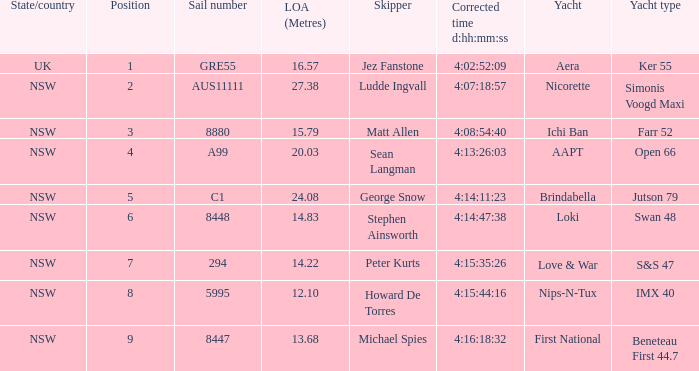For a boat with the correct time of 4:15:35:26, what is the complete sail distance? 14.22. Can you parse all the data within this table? {'header': ['State/country', 'Position', 'Sail number', 'LOA (Metres)', 'Skipper', 'Corrected time d:hh:mm:ss', 'Yacht', 'Yacht type'], 'rows': [['UK', '1', 'GRE55', '16.57', 'Jez Fanstone', '4:02:52:09', 'Aera', 'Ker 55'], ['NSW', '2', 'AUS11111', '27.38', 'Ludde Ingvall', '4:07:18:57', 'Nicorette', 'Simonis Voogd Maxi'], ['NSW', '3', '8880', '15.79', 'Matt Allen', '4:08:54:40', 'Ichi Ban', 'Farr 52'], ['NSW', '4', 'A99', '20.03', 'Sean Langman', '4:13:26:03', 'AAPT', 'Open 66'], ['NSW', '5', 'C1', '24.08', 'George Snow', '4:14:11:23', 'Brindabella', 'Jutson 79'], ['NSW', '6', '8448', '14.83', 'Stephen Ainsworth', '4:14:47:38', 'Loki', 'Swan 48'], ['NSW', '7', '294', '14.22', 'Peter Kurts', '4:15:35:26', 'Love & War', 'S&S 47'], ['NSW', '8', '5995', '12.10', 'Howard De Torres', '4:15:44:16', 'Nips-N-Tux', 'IMX 40'], ['NSW', '9', '8447', '13.68', 'Michael Spies', '4:16:18:32', 'First National', 'Beneteau First 44.7']]} 